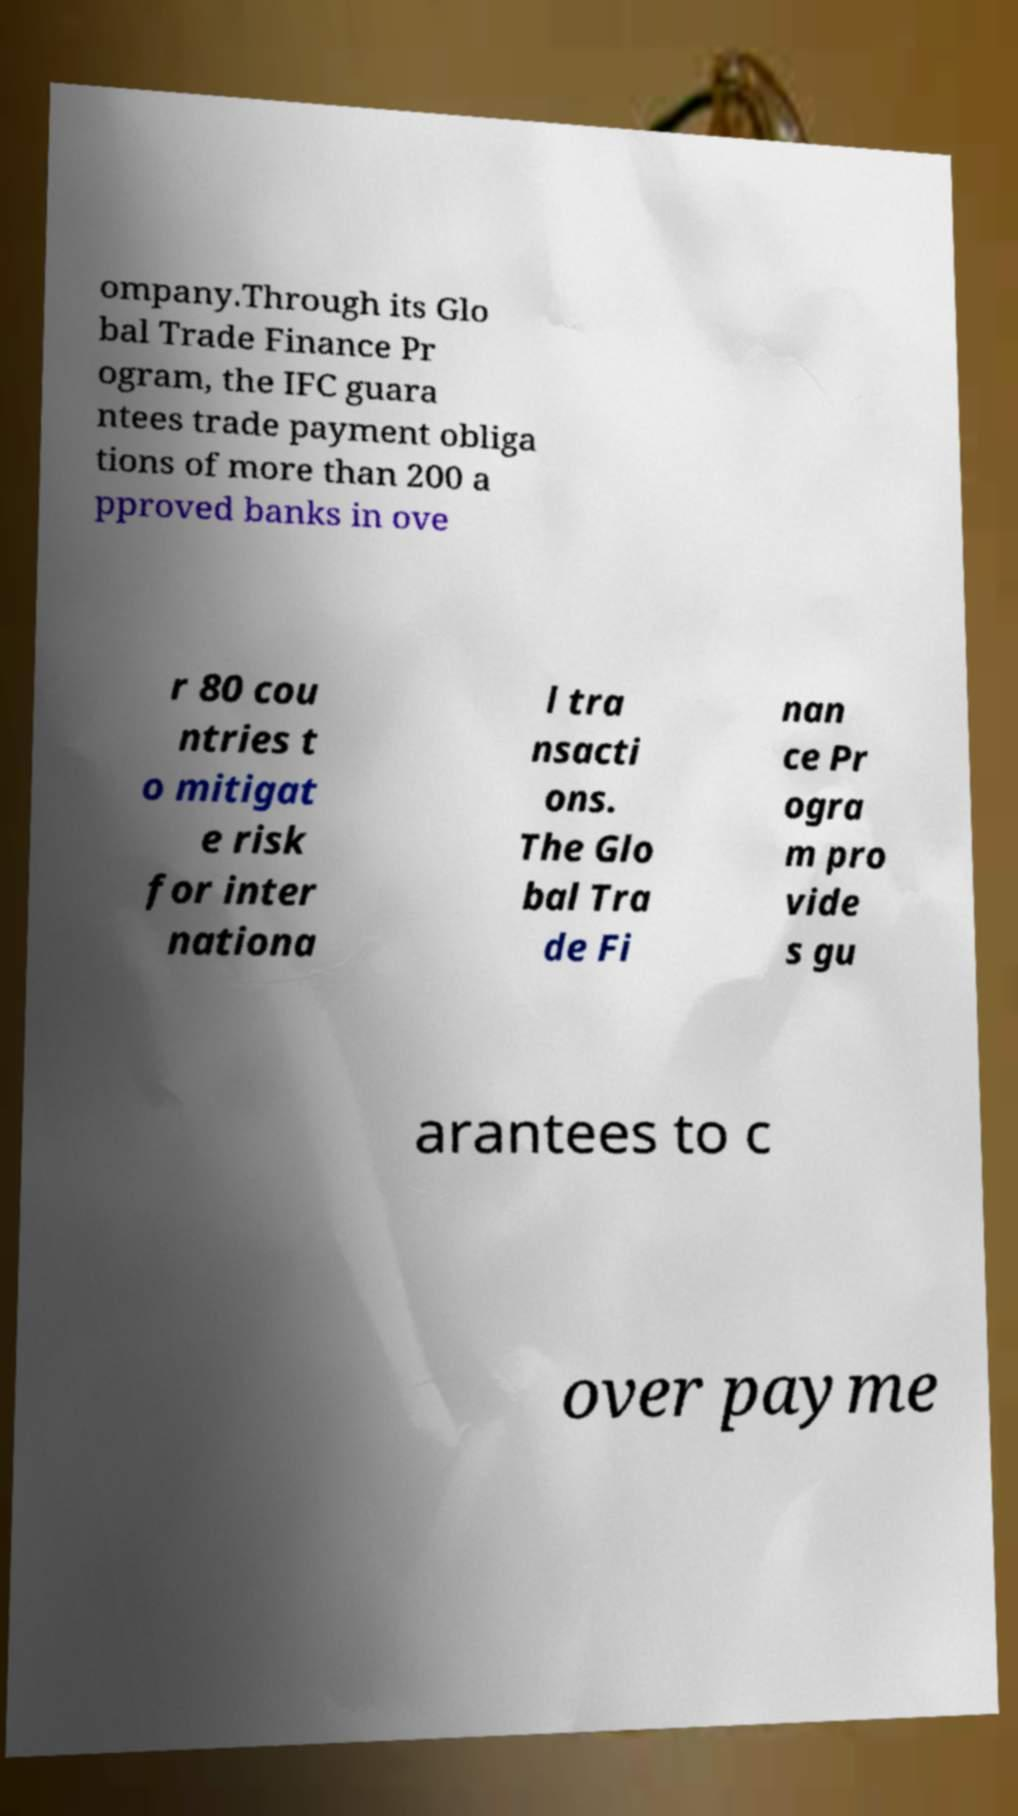Please read and relay the text visible in this image. What does it say? ompany.Through its Glo bal Trade Finance Pr ogram, the IFC guara ntees trade payment obliga tions of more than 200 a pproved banks in ove r 80 cou ntries t o mitigat e risk for inter nationa l tra nsacti ons. The Glo bal Tra de Fi nan ce Pr ogra m pro vide s gu arantees to c over payme 